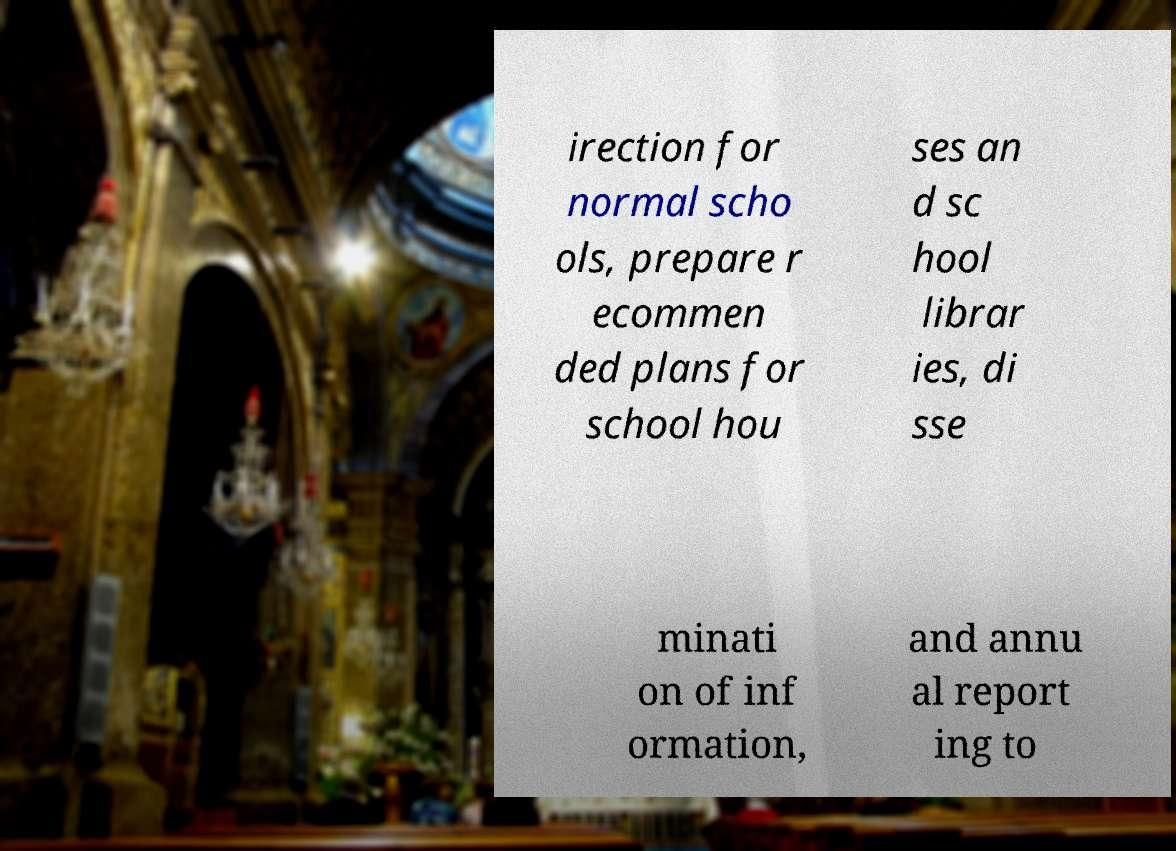Please read and relay the text visible in this image. What does it say? irection for normal scho ols, prepare r ecommen ded plans for school hou ses an d sc hool librar ies, di sse minati on of inf ormation, and annu al report ing to 